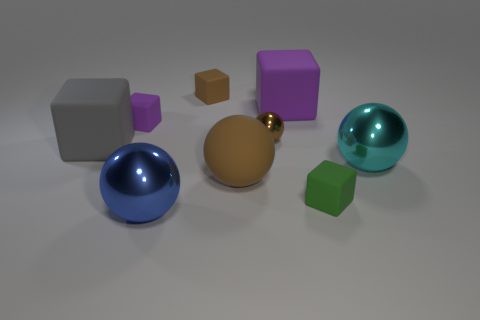What number of brown matte cubes are in front of the tiny matte thing in front of the purple matte block on the left side of the large blue metal sphere?
Offer a terse response. 0. There is a large metallic thing right of the big purple rubber thing; is it the same shape as the purple matte object that is right of the small purple object?
Your answer should be very brief. No. What number of objects are yellow cylinders or cubes?
Keep it short and to the point. 5. What material is the large thing in front of the small rubber cube in front of the cyan shiny thing made of?
Offer a terse response. Metal. Is there a small metal sphere that has the same color as the big rubber ball?
Provide a short and direct response. Yes. What color is the metallic object that is the same size as the green cube?
Your answer should be compact. Brown. The big cube that is behind the large block that is in front of the large matte block that is behind the tiny metallic sphere is made of what material?
Offer a very short reply. Rubber. There is a tiny sphere; is it the same color as the small matte cube that is in front of the big gray object?
Your response must be concise. No. How many objects are large metallic objects on the right side of the large purple cube or spheres that are in front of the green object?
Keep it short and to the point. 2. The tiny thing to the right of the brown ball that is right of the rubber ball is what shape?
Your answer should be compact. Cube. 